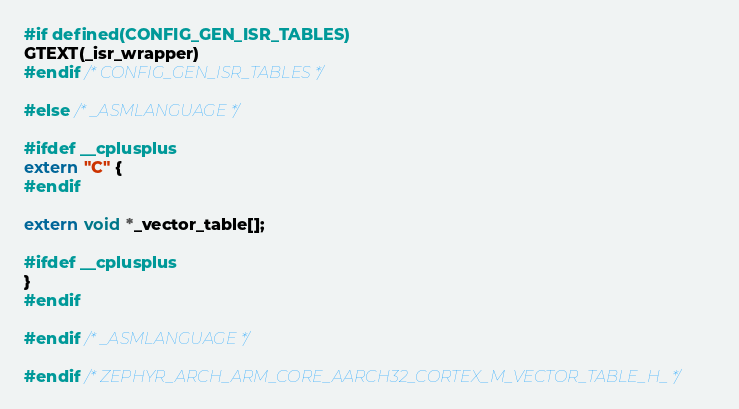<code> <loc_0><loc_0><loc_500><loc_500><_C_>#if defined(CONFIG_GEN_ISR_TABLES)
GTEXT(_isr_wrapper)
#endif /* CONFIG_GEN_ISR_TABLES */

#else /* _ASMLANGUAGE */

#ifdef __cplusplus
extern "C" {
#endif

extern void *_vector_table[];

#ifdef __cplusplus
}
#endif

#endif /* _ASMLANGUAGE */

#endif /* ZEPHYR_ARCH_ARM_CORE_AARCH32_CORTEX_M_VECTOR_TABLE_H_ */
</code> 